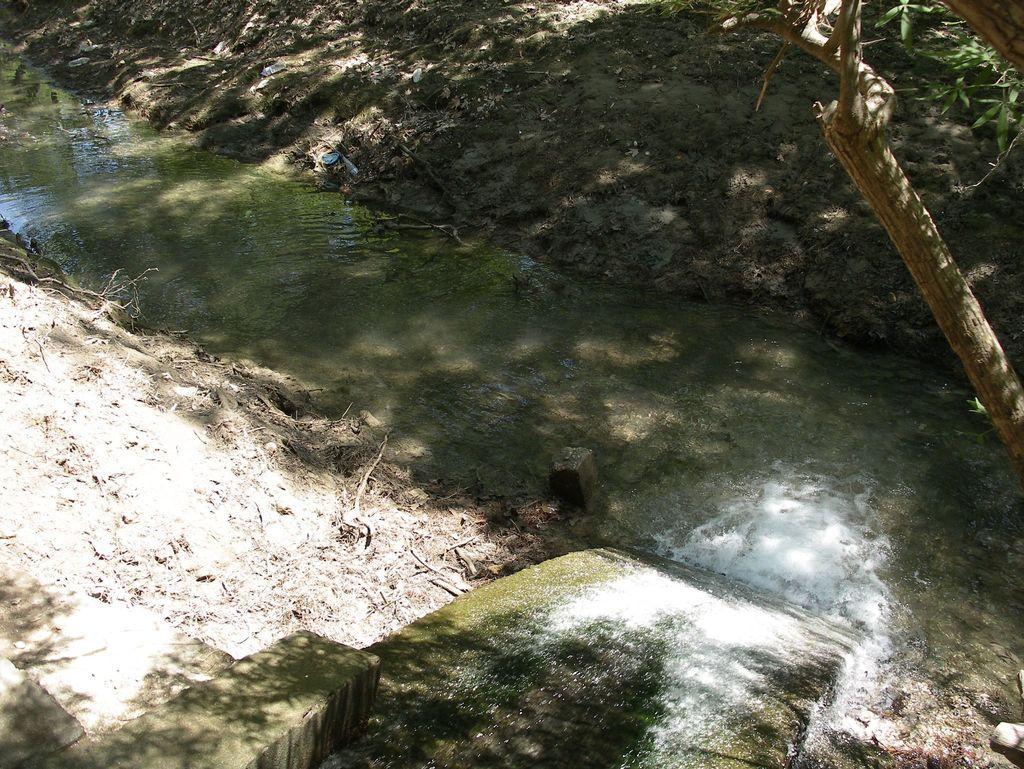Can you describe this image briefly? In the foreground of the image we can see a slider on which some water body is flowing. In the middle of the image we can see water body and a branch of the tree. On the top of the image we can see mud. 